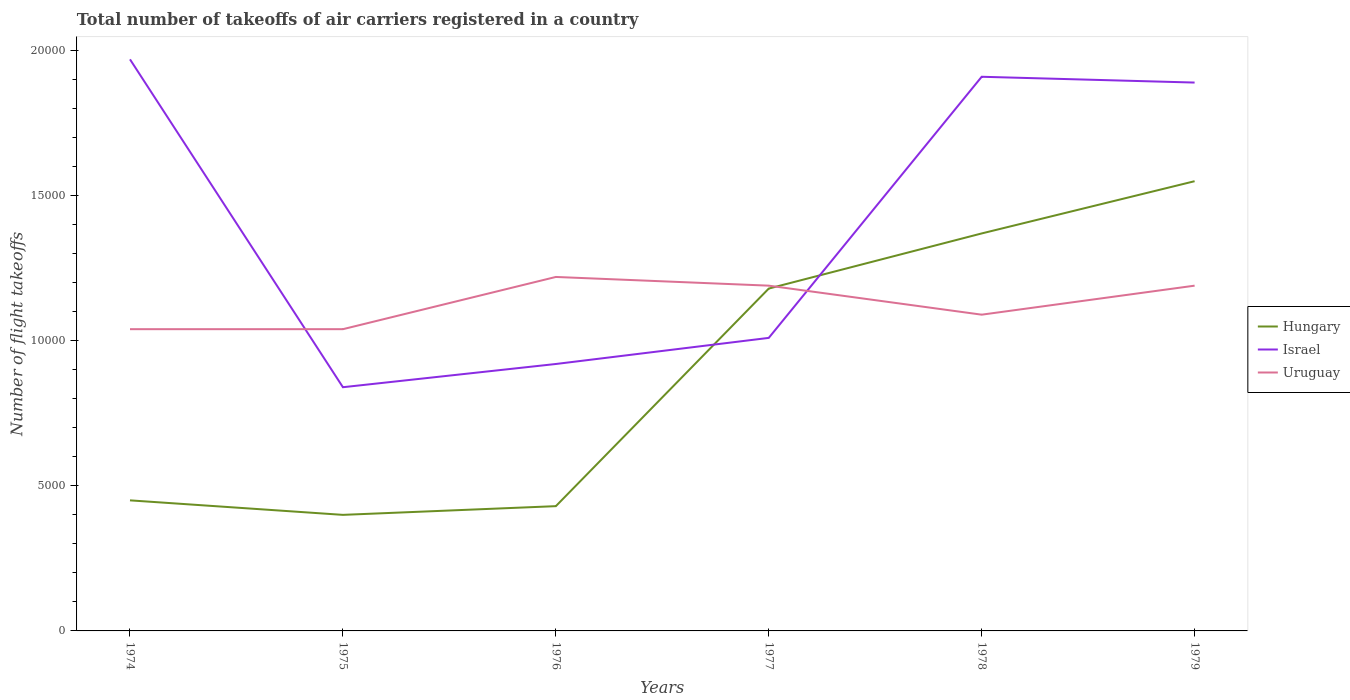How many different coloured lines are there?
Offer a very short reply. 3. Does the line corresponding to Uruguay intersect with the line corresponding to Hungary?
Offer a terse response. Yes. Across all years, what is the maximum total number of flight takeoffs in Israel?
Keep it short and to the point. 8400. In which year was the total number of flight takeoffs in Uruguay maximum?
Give a very brief answer. 1974. What is the total total number of flight takeoffs in Uruguay in the graph?
Your answer should be very brief. -1500. What is the difference between the highest and the second highest total number of flight takeoffs in Uruguay?
Your answer should be very brief. 1800. Is the total number of flight takeoffs in Uruguay strictly greater than the total number of flight takeoffs in Israel over the years?
Your answer should be very brief. No. What is the difference between two consecutive major ticks on the Y-axis?
Your response must be concise. 5000. Are the values on the major ticks of Y-axis written in scientific E-notation?
Offer a terse response. No. Where does the legend appear in the graph?
Provide a short and direct response. Center right. How are the legend labels stacked?
Give a very brief answer. Vertical. What is the title of the graph?
Offer a very short reply. Total number of takeoffs of air carriers registered in a country. What is the label or title of the Y-axis?
Give a very brief answer. Number of flight takeoffs. What is the Number of flight takeoffs in Hungary in 1974?
Your answer should be compact. 4500. What is the Number of flight takeoffs in Israel in 1974?
Give a very brief answer. 1.97e+04. What is the Number of flight takeoffs in Uruguay in 1974?
Provide a short and direct response. 1.04e+04. What is the Number of flight takeoffs in Hungary in 1975?
Provide a succinct answer. 4000. What is the Number of flight takeoffs in Israel in 1975?
Ensure brevity in your answer.  8400. What is the Number of flight takeoffs in Uruguay in 1975?
Your answer should be very brief. 1.04e+04. What is the Number of flight takeoffs of Hungary in 1976?
Give a very brief answer. 4300. What is the Number of flight takeoffs of Israel in 1976?
Give a very brief answer. 9200. What is the Number of flight takeoffs in Uruguay in 1976?
Your answer should be very brief. 1.22e+04. What is the Number of flight takeoffs of Hungary in 1977?
Provide a short and direct response. 1.18e+04. What is the Number of flight takeoffs in Israel in 1977?
Offer a terse response. 1.01e+04. What is the Number of flight takeoffs in Uruguay in 1977?
Give a very brief answer. 1.19e+04. What is the Number of flight takeoffs of Hungary in 1978?
Keep it short and to the point. 1.37e+04. What is the Number of flight takeoffs of Israel in 1978?
Ensure brevity in your answer.  1.91e+04. What is the Number of flight takeoffs in Uruguay in 1978?
Give a very brief answer. 1.09e+04. What is the Number of flight takeoffs in Hungary in 1979?
Your response must be concise. 1.55e+04. What is the Number of flight takeoffs in Israel in 1979?
Provide a short and direct response. 1.89e+04. What is the Number of flight takeoffs in Uruguay in 1979?
Provide a succinct answer. 1.19e+04. Across all years, what is the maximum Number of flight takeoffs of Hungary?
Your response must be concise. 1.55e+04. Across all years, what is the maximum Number of flight takeoffs of Israel?
Make the answer very short. 1.97e+04. Across all years, what is the maximum Number of flight takeoffs of Uruguay?
Offer a terse response. 1.22e+04. Across all years, what is the minimum Number of flight takeoffs in Hungary?
Offer a terse response. 4000. Across all years, what is the minimum Number of flight takeoffs of Israel?
Your answer should be compact. 8400. Across all years, what is the minimum Number of flight takeoffs in Uruguay?
Give a very brief answer. 1.04e+04. What is the total Number of flight takeoffs in Hungary in the graph?
Your response must be concise. 5.38e+04. What is the total Number of flight takeoffs in Israel in the graph?
Ensure brevity in your answer.  8.54e+04. What is the total Number of flight takeoffs of Uruguay in the graph?
Offer a very short reply. 6.77e+04. What is the difference between the Number of flight takeoffs of Israel in 1974 and that in 1975?
Provide a succinct answer. 1.13e+04. What is the difference between the Number of flight takeoffs in Uruguay in 1974 and that in 1975?
Provide a succinct answer. 0. What is the difference between the Number of flight takeoffs in Israel in 1974 and that in 1976?
Your response must be concise. 1.05e+04. What is the difference between the Number of flight takeoffs in Uruguay in 1974 and that in 1976?
Offer a very short reply. -1800. What is the difference between the Number of flight takeoffs of Hungary in 1974 and that in 1977?
Your response must be concise. -7300. What is the difference between the Number of flight takeoffs of Israel in 1974 and that in 1977?
Your response must be concise. 9600. What is the difference between the Number of flight takeoffs in Uruguay in 1974 and that in 1977?
Your answer should be compact. -1500. What is the difference between the Number of flight takeoffs in Hungary in 1974 and that in 1978?
Your response must be concise. -9200. What is the difference between the Number of flight takeoffs of Israel in 1974 and that in 1978?
Give a very brief answer. 600. What is the difference between the Number of flight takeoffs in Uruguay in 1974 and that in 1978?
Provide a short and direct response. -500. What is the difference between the Number of flight takeoffs in Hungary in 1974 and that in 1979?
Make the answer very short. -1.10e+04. What is the difference between the Number of flight takeoffs in Israel in 1974 and that in 1979?
Keep it short and to the point. 800. What is the difference between the Number of flight takeoffs in Uruguay in 1974 and that in 1979?
Keep it short and to the point. -1500. What is the difference between the Number of flight takeoffs of Hungary in 1975 and that in 1976?
Your answer should be very brief. -300. What is the difference between the Number of flight takeoffs of Israel in 1975 and that in 1976?
Give a very brief answer. -800. What is the difference between the Number of flight takeoffs in Uruguay in 1975 and that in 1976?
Offer a terse response. -1800. What is the difference between the Number of flight takeoffs in Hungary in 1975 and that in 1977?
Your answer should be very brief. -7800. What is the difference between the Number of flight takeoffs in Israel in 1975 and that in 1977?
Your response must be concise. -1700. What is the difference between the Number of flight takeoffs of Uruguay in 1975 and that in 1977?
Make the answer very short. -1500. What is the difference between the Number of flight takeoffs of Hungary in 1975 and that in 1978?
Provide a short and direct response. -9700. What is the difference between the Number of flight takeoffs in Israel in 1975 and that in 1978?
Offer a terse response. -1.07e+04. What is the difference between the Number of flight takeoffs in Uruguay in 1975 and that in 1978?
Offer a very short reply. -500. What is the difference between the Number of flight takeoffs of Hungary in 1975 and that in 1979?
Offer a very short reply. -1.15e+04. What is the difference between the Number of flight takeoffs in Israel in 1975 and that in 1979?
Give a very brief answer. -1.05e+04. What is the difference between the Number of flight takeoffs of Uruguay in 1975 and that in 1979?
Your response must be concise. -1500. What is the difference between the Number of flight takeoffs in Hungary in 1976 and that in 1977?
Offer a terse response. -7500. What is the difference between the Number of flight takeoffs of Israel in 1976 and that in 1977?
Ensure brevity in your answer.  -900. What is the difference between the Number of flight takeoffs in Uruguay in 1976 and that in 1977?
Make the answer very short. 300. What is the difference between the Number of flight takeoffs in Hungary in 1976 and that in 1978?
Offer a terse response. -9400. What is the difference between the Number of flight takeoffs in Israel in 1976 and that in 1978?
Give a very brief answer. -9900. What is the difference between the Number of flight takeoffs of Uruguay in 1976 and that in 1978?
Provide a succinct answer. 1300. What is the difference between the Number of flight takeoffs in Hungary in 1976 and that in 1979?
Provide a short and direct response. -1.12e+04. What is the difference between the Number of flight takeoffs of Israel in 1976 and that in 1979?
Provide a succinct answer. -9700. What is the difference between the Number of flight takeoffs in Uruguay in 1976 and that in 1979?
Provide a succinct answer. 300. What is the difference between the Number of flight takeoffs of Hungary in 1977 and that in 1978?
Offer a terse response. -1900. What is the difference between the Number of flight takeoffs of Israel in 1977 and that in 1978?
Your response must be concise. -9000. What is the difference between the Number of flight takeoffs of Hungary in 1977 and that in 1979?
Keep it short and to the point. -3700. What is the difference between the Number of flight takeoffs of Israel in 1977 and that in 1979?
Offer a terse response. -8800. What is the difference between the Number of flight takeoffs of Hungary in 1978 and that in 1979?
Offer a terse response. -1800. What is the difference between the Number of flight takeoffs in Israel in 1978 and that in 1979?
Your answer should be very brief. 200. What is the difference between the Number of flight takeoffs in Uruguay in 1978 and that in 1979?
Make the answer very short. -1000. What is the difference between the Number of flight takeoffs of Hungary in 1974 and the Number of flight takeoffs of Israel in 1975?
Provide a short and direct response. -3900. What is the difference between the Number of flight takeoffs of Hungary in 1974 and the Number of flight takeoffs of Uruguay in 1975?
Keep it short and to the point. -5900. What is the difference between the Number of flight takeoffs of Israel in 1974 and the Number of flight takeoffs of Uruguay in 1975?
Provide a succinct answer. 9300. What is the difference between the Number of flight takeoffs in Hungary in 1974 and the Number of flight takeoffs in Israel in 1976?
Offer a very short reply. -4700. What is the difference between the Number of flight takeoffs of Hungary in 1974 and the Number of flight takeoffs of Uruguay in 1976?
Offer a terse response. -7700. What is the difference between the Number of flight takeoffs of Israel in 1974 and the Number of flight takeoffs of Uruguay in 1976?
Offer a very short reply. 7500. What is the difference between the Number of flight takeoffs in Hungary in 1974 and the Number of flight takeoffs in Israel in 1977?
Provide a short and direct response. -5600. What is the difference between the Number of flight takeoffs of Hungary in 1974 and the Number of flight takeoffs of Uruguay in 1977?
Your answer should be compact. -7400. What is the difference between the Number of flight takeoffs of Israel in 1974 and the Number of flight takeoffs of Uruguay in 1977?
Your response must be concise. 7800. What is the difference between the Number of flight takeoffs in Hungary in 1974 and the Number of flight takeoffs in Israel in 1978?
Keep it short and to the point. -1.46e+04. What is the difference between the Number of flight takeoffs in Hungary in 1974 and the Number of flight takeoffs in Uruguay in 1978?
Offer a terse response. -6400. What is the difference between the Number of flight takeoffs in Israel in 1974 and the Number of flight takeoffs in Uruguay in 1978?
Your answer should be compact. 8800. What is the difference between the Number of flight takeoffs in Hungary in 1974 and the Number of flight takeoffs in Israel in 1979?
Provide a short and direct response. -1.44e+04. What is the difference between the Number of flight takeoffs in Hungary in 1974 and the Number of flight takeoffs in Uruguay in 1979?
Your answer should be compact. -7400. What is the difference between the Number of flight takeoffs of Israel in 1974 and the Number of flight takeoffs of Uruguay in 1979?
Offer a very short reply. 7800. What is the difference between the Number of flight takeoffs in Hungary in 1975 and the Number of flight takeoffs in Israel in 1976?
Offer a terse response. -5200. What is the difference between the Number of flight takeoffs in Hungary in 1975 and the Number of flight takeoffs in Uruguay in 1976?
Offer a very short reply. -8200. What is the difference between the Number of flight takeoffs in Israel in 1975 and the Number of flight takeoffs in Uruguay in 1976?
Give a very brief answer. -3800. What is the difference between the Number of flight takeoffs in Hungary in 1975 and the Number of flight takeoffs in Israel in 1977?
Offer a very short reply. -6100. What is the difference between the Number of flight takeoffs of Hungary in 1975 and the Number of flight takeoffs of Uruguay in 1977?
Make the answer very short. -7900. What is the difference between the Number of flight takeoffs of Israel in 1975 and the Number of flight takeoffs of Uruguay in 1977?
Keep it short and to the point. -3500. What is the difference between the Number of flight takeoffs of Hungary in 1975 and the Number of flight takeoffs of Israel in 1978?
Make the answer very short. -1.51e+04. What is the difference between the Number of flight takeoffs of Hungary in 1975 and the Number of flight takeoffs of Uruguay in 1978?
Keep it short and to the point. -6900. What is the difference between the Number of flight takeoffs of Israel in 1975 and the Number of flight takeoffs of Uruguay in 1978?
Provide a succinct answer. -2500. What is the difference between the Number of flight takeoffs of Hungary in 1975 and the Number of flight takeoffs of Israel in 1979?
Your response must be concise. -1.49e+04. What is the difference between the Number of flight takeoffs of Hungary in 1975 and the Number of flight takeoffs of Uruguay in 1979?
Offer a terse response. -7900. What is the difference between the Number of flight takeoffs in Israel in 1975 and the Number of flight takeoffs in Uruguay in 1979?
Your answer should be very brief. -3500. What is the difference between the Number of flight takeoffs in Hungary in 1976 and the Number of flight takeoffs in Israel in 1977?
Your answer should be very brief. -5800. What is the difference between the Number of flight takeoffs of Hungary in 1976 and the Number of flight takeoffs of Uruguay in 1977?
Make the answer very short. -7600. What is the difference between the Number of flight takeoffs of Israel in 1976 and the Number of flight takeoffs of Uruguay in 1977?
Your response must be concise. -2700. What is the difference between the Number of flight takeoffs of Hungary in 1976 and the Number of flight takeoffs of Israel in 1978?
Provide a succinct answer. -1.48e+04. What is the difference between the Number of flight takeoffs in Hungary in 1976 and the Number of flight takeoffs in Uruguay in 1978?
Provide a short and direct response. -6600. What is the difference between the Number of flight takeoffs of Israel in 1976 and the Number of flight takeoffs of Uruguay in 1978?
Ensure brevity in your answer.  -1700. What is the difference between the Number of flight takeoffs of Hungary in 1976 and the Number of flight takeoffs of Israel in 1979?
Keep it short and to the point. -1.46e+04. What is the difference between the Number of flight takeoffs of Hungary in 1976 and the Number of flight takeoffs of Uruguay in 1979?
Ensure brevity in your answer.  -7600. What is the difference between the Number of flight takeoffs in Israel in 1976 and the Number of flight takeoffs in Uruguay in 1979?
Offer a terse response. -2700. What is the difference between the Number of flight takeoffs in Hungary in 1977 and the Number of flight takeoffs in Israel in 1978?
Offer a very short reply. -7300. What is the difference between the Number of flight takeoffs in Hungary in 1977 and the Number of flight takeoffs in Uruguay in 1978?
Ensure brevity in your answer.  900. What is the difference between the Number of flight takeoffs in Israel in 1977 and the Number of flight takeoffs in Uruguay in 1978?
Provide a succinct answer. -800. What is the difference between the Number of flight takeoffs of Hungary in 1977 and the Number of flight takeoffs of Israel in 1979?
Your answer should be very brief. -7100. What is the difference between the Number of flight takeoffs of Hungary in 1977 and the Number of flight takeoffs of Uruguay in 1979?
Your answer should be very brief. -100. What is the difference between the Number of flight takeoffs in Israel in 1977 and the Number of flight takeoffs in Uruguay in 1979?
Your answer should be compact. -1800. What is the difference between the Number of flight takeoffs of Hungary in 1978 and the Number of flight takeoffs of Israel in 1979?
Provide a short and direct response. -5200. What is the difference between the Number of flight takeoffs of Hungary in 1978 and the Number of flight takeoffs of Uruguay in 1979?
Your answer should be very brief. 1800. What is the difference between the Number of flight takeoffs of Israel in 1978 and the Number of flight takeoffs of Uruguay in 1979?
Your response must be concise. 7200. What is the average Number of flight takeoffs in Hungary per year?
Your response must be concise. 8966.67. What is the average Number of flight takeoffs of Israel per year?
Offer a very short reply. 1.42e+04. What is the average Number of flight takeoffs in Uruguay per year?
Keep it short and to the point. 1.13e+04. In the year 1974, what is the difference between the Number of flight takeoffs in Hungary and Number of flight takeoffs in Israel?
Ensure brevity in your answer.  -1.52e+04. In the year 1974, what is the difference between the Number of flight takeoffs of Hungary and Number of flight takeoffs of Uruguay?
Give a very brief answer. -5900. In the year 1974, what is the difference between the Number of flight takeoffs in Israel and Number of flight takeoffs in Uruguay?
Ensure brevity in your answer.  9300. In the year 1975, what is the difference between the Number of flight takeoffs in Hungary and Number of flight takeoffs in Israel?
Make the answer very short. -4400. In the year 1975, what is the difference between the Number of flight takeoffs in Hungary and Number of flight takeoffs in Uruguay?
Your answer should be very brief. -6400. In the year 1975, what is the difference between the Number of flight takeoffs of Israel and Number of flight takeoffs of Uruguay?
Keep it short and to the point. -2000. In the year 1976, what is the difference between the Number of flight takeoffs in Hungary and Number of flight takeoffs in Israel?
Ensure brevity in your answer.  -4900. In the year 1976, what is the difference between the Number of flight takeoffs in Hungary and Number of flight takeoffs in Uruguay?
Offer a very short reply. -7900. In the year 1976, what is the difference between the Number of flight takeoffs of Israel and Number of flight takeoffs of Uruguay?
Provide a succinct answer. -3000. In the year 1977, what is the difference between the Number of flight takeoffs in Hungary and Number of flight takeoffs in Israel?
Provide a succinct answer. 1700. In the year 1977, what is the difference between the Number of flight takeoffs of Hungary and Number of flight takeoffs of Uruguay?
Give a very brief answer. -100. In the year 1977, what is the difference between the Number of flight takeoffs of Israel and Number of flight takeoffs of Uruguay?
Give a very brief answer. -1800. In the year 1978, what is the difference between the Number of flight takeoffs of Hungary and Number of flight takeoffs of Israel?
Provide a short and direct response. -5400. In the year 1978, what is the difference between the Number of flight takeoffs of Hungary and Number of flight takeoffs of Uruguay?
Your answer should be very brief. 2800. In the year 1978, what is the difference between the Number of flight takeoffs of Israel and Number of flight takeoffs of Uruguay?
Provide a succinct answer. 8200. In the year 1979, what is the difference between the Number of flight takeoffs of Hungary and Number of flight takeoffs of Israel?
Keep it short and to the point. -3400. In the year 1979, what is the difference between the Number of flight takeoffs in Hungary and Number of flight takeoffs in Uruguay?
Your answer should be compact. 3600. In the year 1979, what is the difference between the Number of flight takeoffs in Israel and Number of flight takeoffs in Uruguay?
Your response must be concise. 7000. What is the ratio of the Number of flight takeoffs of Hungary in 1974 to that in 1975?
Give a very brief answer. 1.12. What is the ratio of the Number of flight takeoffs of Israel in 1974 to that in 1975?
Give a very brief answer. 2.35. What is the ratio of the Number of flight takeoffs in Uruguay in 1974 to that in 1975?
Give a very brief answer. 1. What is the ratio of the Number of flight takeoffs in Hungary in 1974 to that in 1976?
Offer a terse response. 1.05. What is the ratio of the Number of flight takeoffs in Israel in 1974 to that in 1976?
Your answer should be very brief. 2.14. What is the ratio of the Number of flight takeoffs in Uruguay in 1974 to that in 1976?
Provide a short and direct response. 0.85. What is the ratio of the Number of flight takeoffs in Hungary in 1974 to that in 1977?
Your answer should be very brief. 0.38. What is the ratio of the Number of flight takeoffs in Israel in 1974 to that in 1977?
Give a very brief answer. 1.95. What is the ratio of the Number of flight takeoffs of Uruguay in 1974 to that in 1977?
Provide a short and direct response. 0.87. What is the ratio of the Number of flight takeoffs of Hungary in 1974 to that in 1978?
Offer a terse response. 0.33. What is the ratio of the Number of flight takeoffs of Israel in 1974 to that in 1978?
Provide a short and direct response. 1.03. What is the ratio of the Number of flight takeoffs in Uruguay in 1974 to that in 1978?
Give a very brief answer. 0.95. What is the ratio of the Number of flight takeoffs of Hungary in 1974 to that in 1979?
Give a very brief answer. 0.29. What is the ratio of the Number of flight takeoffs in Israel in 1974 to that in 1979?
Offer a very short reply. 1.04. What is the ratio of the Number of flight takeoffs in Uruguay in 1974 to that in 1979?
Make the answer very short. 0.87. What is the ratio of the Number of flight takeoffs of Hungary in 1975 to that in 1976?
Give a very brief answer. 0.93. What is the ratio of the Number of flight takeoffs of Uruguay in 1975 to that in 1976?
Provide a succinct answer. 0.85. What is the ratio of the Number of flight takeoffs of Hungary in 1975 to that in 1977?
Your answer should be very brief. 0.34. What is the ratio of the Number of flight takeoffs in Israel in 1975 to that in 1977?
Make the answer very short. 0.83. What is the ratio of the Number of flight takeoffs in Uruguay in 1975 to that in 1977?
Give a very brief answer. 0.87. What is the ratio of the Number of flight takeoffs of Hungary in 1975 to that in 1978?
Make the answer very short. 0.29. What is the ratio of the Number of flight takeoffs of Israel in 1975 to that in 1978?
Offer a terse response. 0.44. What is the ratio of the Number of flight takeoffs in Uruguay in 1975 to that in 1978?
Offer a very short reply. 0.95. What is the ratio of the Number of flight takeoffs in Hungary in 1975 to that in 1979?
Provide a succinct answer. 0.26. What is the ratio of the Number of flight takeoffs of Israel in 1975 to that in 1979?
Make the answer very short. 0.44. What is the ratio of the Number of flight takeoffs of Uruguay in 1975 to that in 1979?
Keep it short and to the point. 0.87. What is the ratio of the Number of flight takeoffs of Hungary in 1976 to that in 1977?
Your response must be concise. 0.36. What is the ratio of the Number of flight takeoffs in Israel in 1976 to that in 1977?
Provide a short and direct response. 0.91. What is the ratio of the Number of flight takeoffs of Uruguay in 1976 to that in 1977?
Ensure brevity in your answer.  1.03. What is the ratio of the Number of flight takeoffs of Hungary in 1976 to that in 1978?
Provide a succinct answer. 0.31. What is the ratio of the Number of flight takeoffs in Israel in 1976 to that in 1978?
Offer a terse response. 0.48. What is the ratio of the Number of flight takeoffs of Uruguay in 1976 to that in 1978?
Ensure brevity in your answer.  1.12. What is the ratio of the Number of flight takeoffs in Hungary in 1976 to that in 1979?
Keep it short and to the point. 0.28. What is the ratio of the Number of flight takeoffs of Israel in 1976 to that in 1979?
Offer a very short reply. 0.49. What is the ratio of the Number of flight takeoffs of Uruguay in 1976 to that in 1979?
Provide a short and direct response. 1.03. What is the ratio of the Number of flight takeoffs of Hungary in 1977 to that in 1978?
Your answer should be very brief. 0.86. What is the ratio of the Number of flight takeoffs in Israel in 1977 to that in 1978?
Keep it short and to the point. 0.53. What is the ratio of the Number of flight takeoffs in Uruguay in 1977 to that in 1978?
Your answer should be very brief. 1.09. What is the ratio of the Number of flight takeoffs in Hungary in 1977 to that in 1979?
Ensure brevity in your answer.  0.76. What is the ratio of the Number of flight takeoffs in Israel in 1977 to that in 1979?
Your response must be concise. 0.53. What is the ratio of the Number of flight takeoffs of Uruguay in 1977 to that in 1979?
Make the answer very short. 1. What is the ratio of the Number of flight takeoffs of Hungary in 1978 to that in 1979?
Make the answer very short. 0.88. What is the ratio of the Number of flight takeoffs of Israel in 1978 to that in 1979?
Give a very brief answer. 1.01. What is the ratio of the Number of flight takeoffs of Uruguay in 1978 to that in 1979?
Your answer should be very brief. 0.92. What is the difference between the highest and the second highest Number of flight takeoffs in Hungary?
Ensure brevity in your answer.  1800. What is the difference between the highest and the second highest Number of flight takeoffs of Israel?
Your answer should be very brief. 600. What is the difference between the highest and the second highest Number of flight takeoffs in Uruguay?
Provide a short and direct response. 300. What is the difference between the highest and the lowest Number of flight takeoffs of Hungary?
Provide a short and direct response. 1.15e+04. What is the difference between the highest and the lowest Number of flight takeoffs of Israel?
Offer a very short reply. 1.13e+04. What is the difference between the highest and the lowest Number of flight takeoffs in Uruguay?
Provide a succinct answer. 1800. 